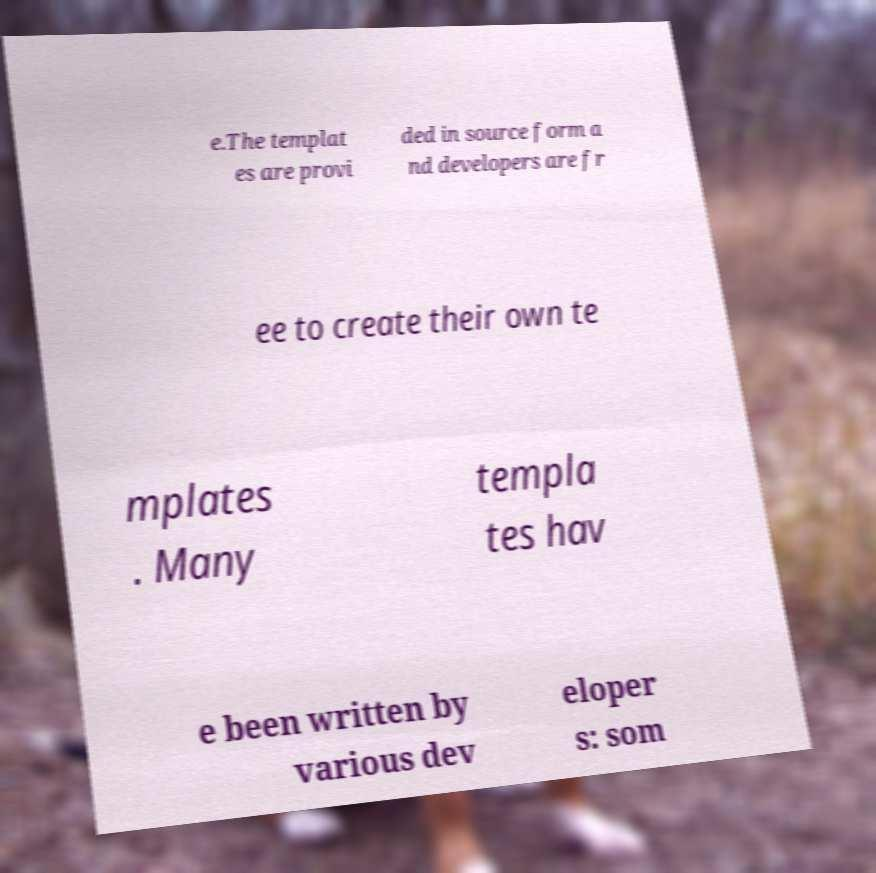Can you accurately transcribe the text from the provided image for me? e.The templat es are provi ded in source form a nd developers are fr ee to create their own te mplates . Many templa tes hav e been written by various dev eloper s: som 